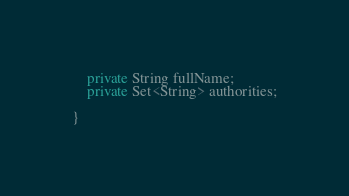<code> <loc_0><loc_0><loc_500><loc_500><_Java_>    private String fullName;
    private Set<String> authorities;

}
</code> 